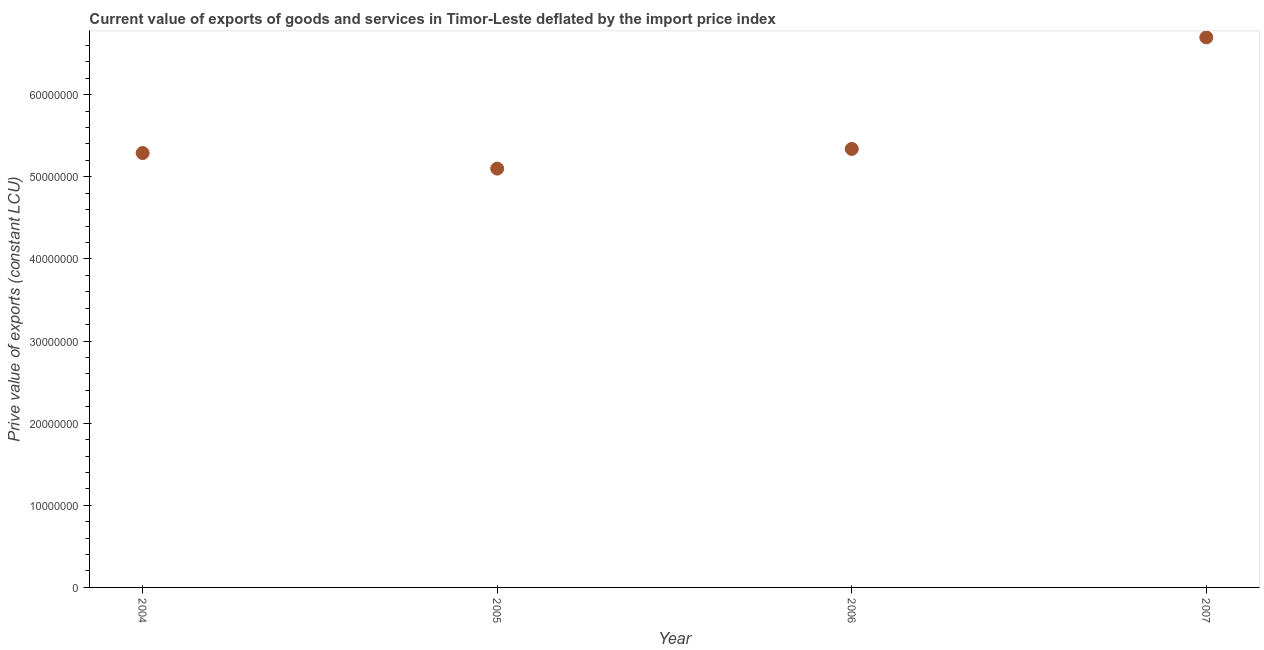What is the price value of exports in 2006?
Offer a terse response. 5.34e+07. Across all years, what is the maximum price value of exports?
Offer a terse response. 6.70e+07. Across all years, what is the minimum price value of exports?
Keep it short and to the point. 5.10e+07. What is the sum of the price value of exports?
Your response must be concise. 2.24e+08. What is the difference between the price value of exports in 2005 and 2006?
Keep it short and to the point. -2.39e+06. What is the average price value of exports per year?
Your response must be concise. 5.61e+07. What is the median price value of exports?
Give a very brief answer. 5.31e+07. Do a majority of the years between 2005 and 2004 (inclusive) have price value of exports greater than 52000000 LCU?
Give a very brief answer. No. What is the ratio of the price value of exports in 2006 to that in 2007?
Give a very brief answer. 0.8. What is the difference between the highest and the second highest price value of exports?
Provide a short and direct response. 1.36e+07. What is the difference between the highest and the lowest price value of exports?
Give a very brief answer. 1.60e+07. In how many years, is the price value of exports greater than the average price value of exports taken over all years?
Ensure brevity in your answer.  1. What is the title of the graph?
Offer a terse response. Current value of exports of goods and services in Timor-Leste deflated by the import price index. What is the label or title of the Y-axis?
Your response must be concise. Prive value of exports (constant LCU). What is the Prive value of exports (constant LCU) in 2004?
Your answer should be compact. 5.29e+07. What is the Prive value of exports (constant LCU) in 2005?
Your answer should be very brief. 5.10e+07. What is the Prive value of exports (constant LCU) in 2006?
Your answer should be very brief. 5.34e+07. What is the Prive value of exports (constant LCU) in 2007?
Provide a succinct answer. 6.70e+07. What is the difference between the Prive value of exports (constant LCU) in 2004 and 2005?
Give a very brief answer. 1.89e+06. What is the difference between the Prive value of exports (constant LCU) in 2004 and 2006?
Provide a succinct answer. -4.98e+05. What is the difference between the Prive value of exports (constant LCU) in 2004 and 2007?
Your response must be concise. -1.41e+07. What is the difference between the Prive value of exports (constant LCU) in 2005 and 2006?
Offer a terse response. -2.39e+06. What is the difference between the Prive value of exports (constant LCU) in 2005 and 2007?
Give a very brief answer. -1.60e+07. What is the difference between the Prive value of exports (constant LCU) in 2006 and 2007?
Ensure brevity in your answer.  -1.36e+07. What is the ratio of the Prive value of exports (constant LCU) in 2004 to that in 2005?
Give a very brief answer. 1.04. What is the ratio of the Prive value of exports (constant LCU) in 2004 to that in 2007?
Your answer should be compact. 0.79. What is the ratio of the Prive value of exports (constant LCU) in 2005 to that in 2006?
Provide a short and direct response. 0.95. What is the ratio of the Prive value of exports (constant LCU) in 2005 to that in 2007?
Your answer should be compact. 0.76. What is the ratio of the Prive value of exports (constant LCU) in 2006 to that in 2007?
Ensure brevity in your answer.  0.8. 